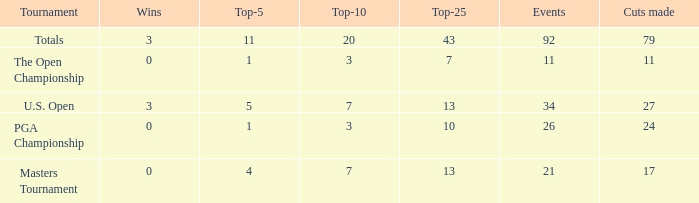Name the tournament for top-5 more thn 1 and top-25 of 13 with wins of 3 U.S. Open. 